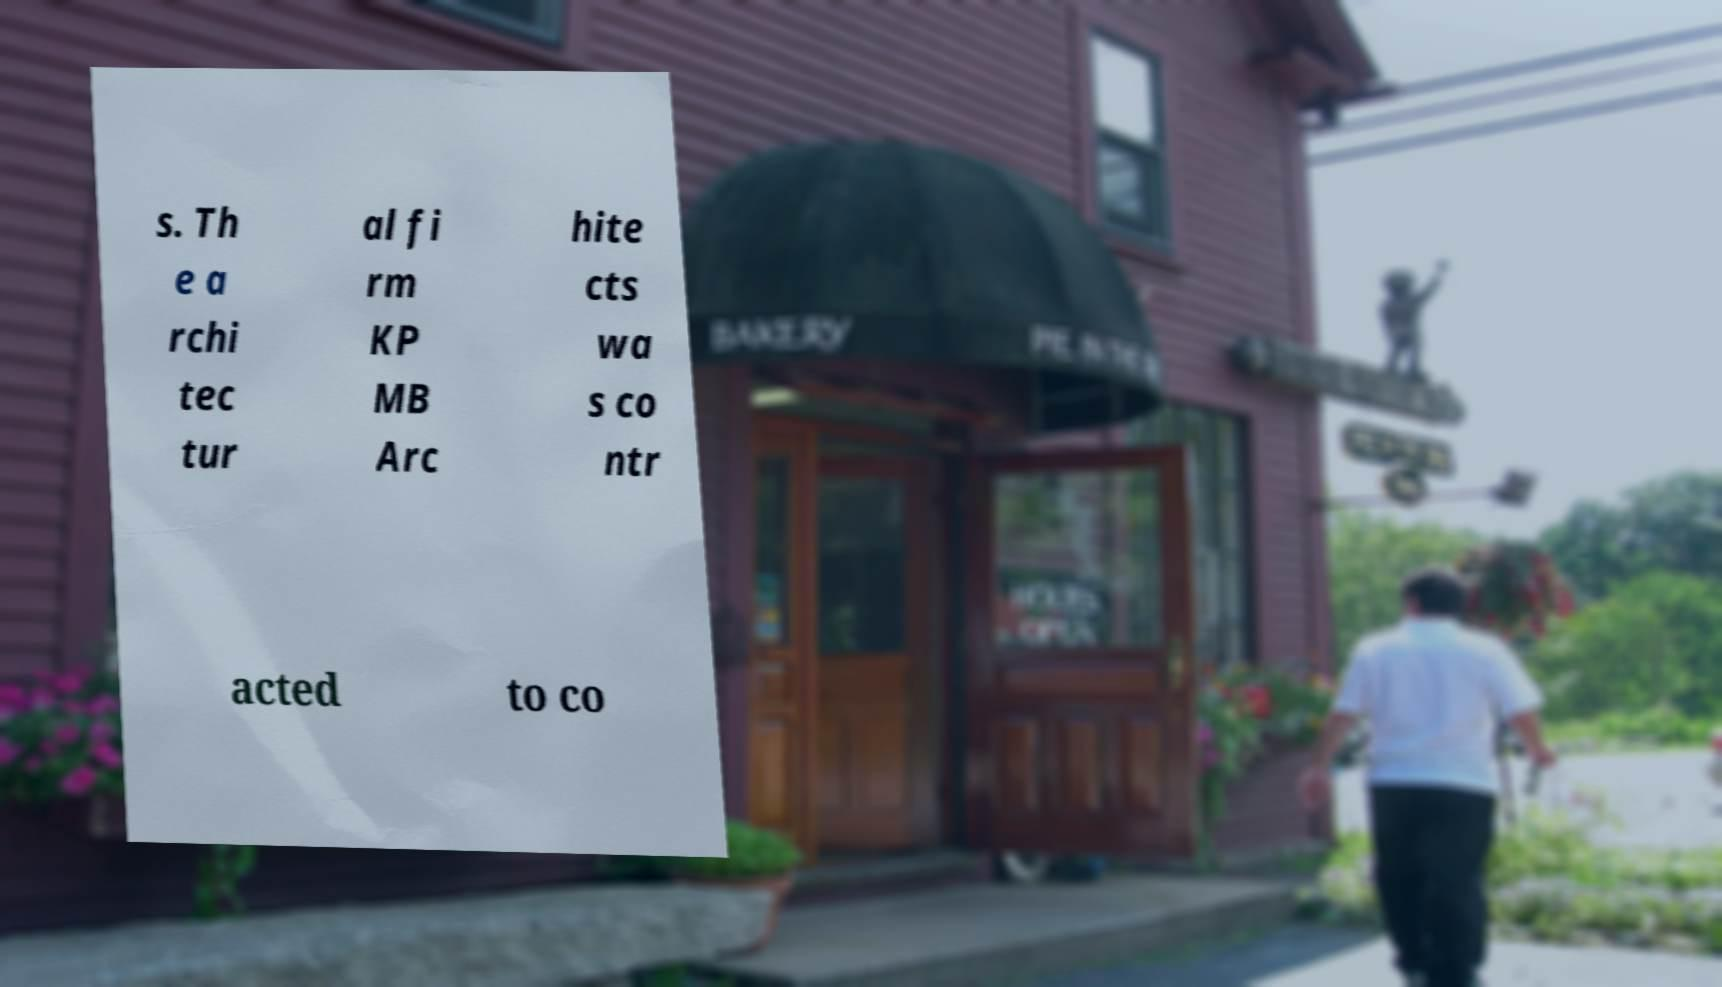There's text embedded in this image that I need extracted. Can you transcribe it verbatim? s. Th e a rchi tec tur al fi rm KP MB Arc hite cts wa s co ntr acted to co 